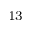<formula> <loc_0><loc_0><loc_500><loc_500>^ { 1 3 }</formula> 